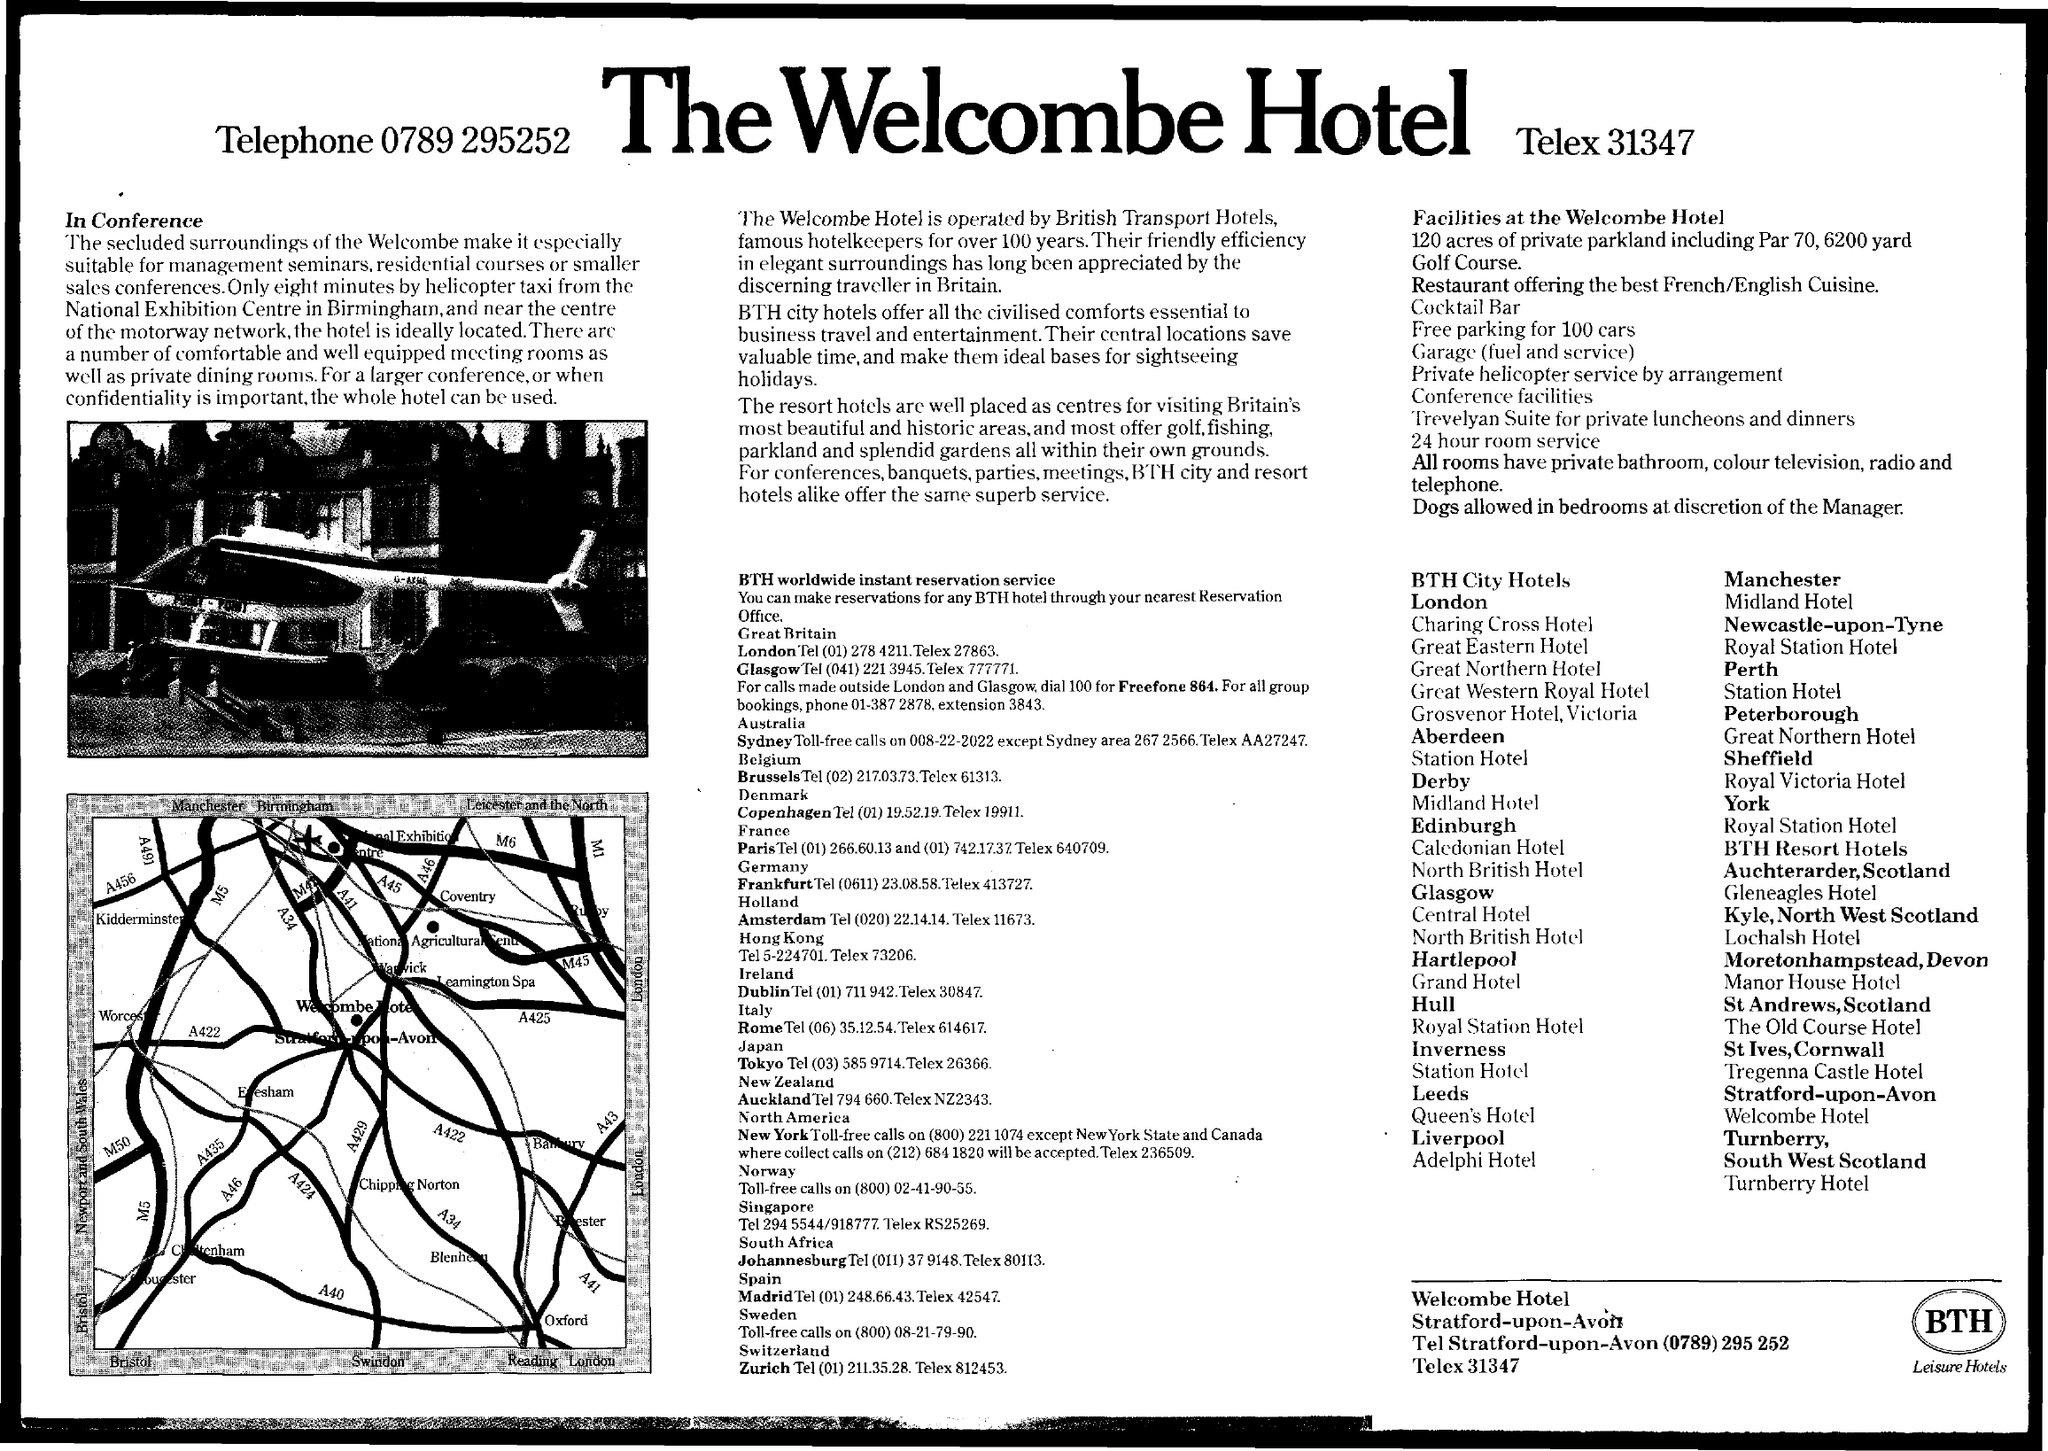Highlight a few significant elements in this photo. The hotel's telex number is 31347... The Welcombe Hotel is the name of the hotel. 